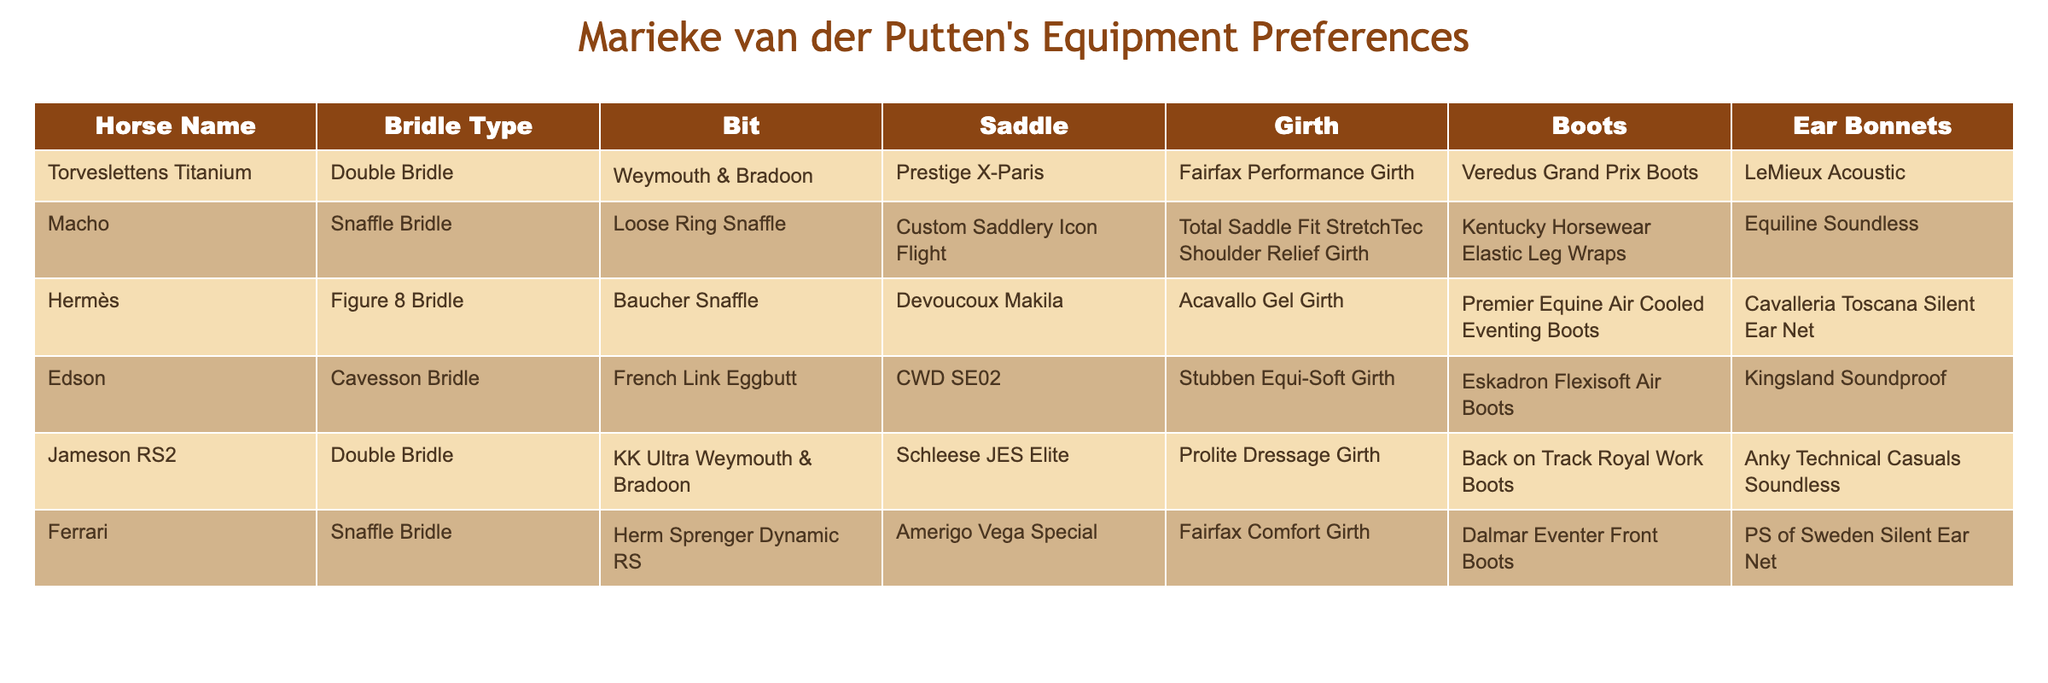What type of bridle is used for Macho? The table indicates that Macho uses a Snaffle Bridle, as stated in the Bridle Type column of the relevant row.
Answer: Snaffle Bridle Which horse has a Double Bridle? The Double Bridle is used by Torveslettens Titanium and Jameson RS2, which can be seen in the respective rows under the Bridle Type column.
Answer: Torveslettens Titanium and Jameson RS2 What bit is used with the CWD SE02 saddle? The CWD SE02 saddle is associated with the French Link Eggbutt bit, as shown in the row for Edson.
Answer: French Link Eggbutt Do any horses use the same type of boots? Yes, both Edson and Jameson RS2 use Back on Track Royal Work Boots; this is observed by checking the Boots column for each horse.
Answer: Yes Which saddle is the most commonly used among the horses? The table shows that there are different unique saddles for each horse, so no saddle is repeated. Therefore, there is no common saddle.
Answer: No common saddle How many different types of bridles are listed in the table? By counting the unique entries in the Bridle Type column, we find five distinct types of bridles listed: Double Bridle, Snaffle Bridle, Figure 8 Bridle, Cavesson Bridle, and a second Double Bridle (for Jameson RS2).
Answer: Five Which horse uses the 'LeMieux Acoustic' ear bonnet? The table shows that 'LeMieux Acoustic' is used with Torveslettens Titanium, which is listed in the Ear Bonnets column of that row.
Answer: Torveslettens Titanium Is there a horse that uses a Loose Ring Snaffle bit? The table displays that Macho uses a Loose Ring Snaffle bit, so the answer is affirmative.
Answer: Yes List the horses that have a Prestige saddle. By looking at the Saddle column, only Torveslettens Titanium uses the Prestige X-Paris saddle, while others use different saddles.
Answer: Torveslettens Titanium What is the only horse that uses the Fairfax Performance Girth? The only horse with the Fairfax Performance Girth is Torveslettens Titanium, as stated in the Girth column.
Answer: Torveslettens Titanium Which horse has both boots and an ear bonnet from 'PS of Sweden'? The horse Ferrari uses Dalmar Eventer Front Boots and the 'PS of Sweden Silent Ear Net', as shown in the respective columns for those items.
Answer: Ferrari 